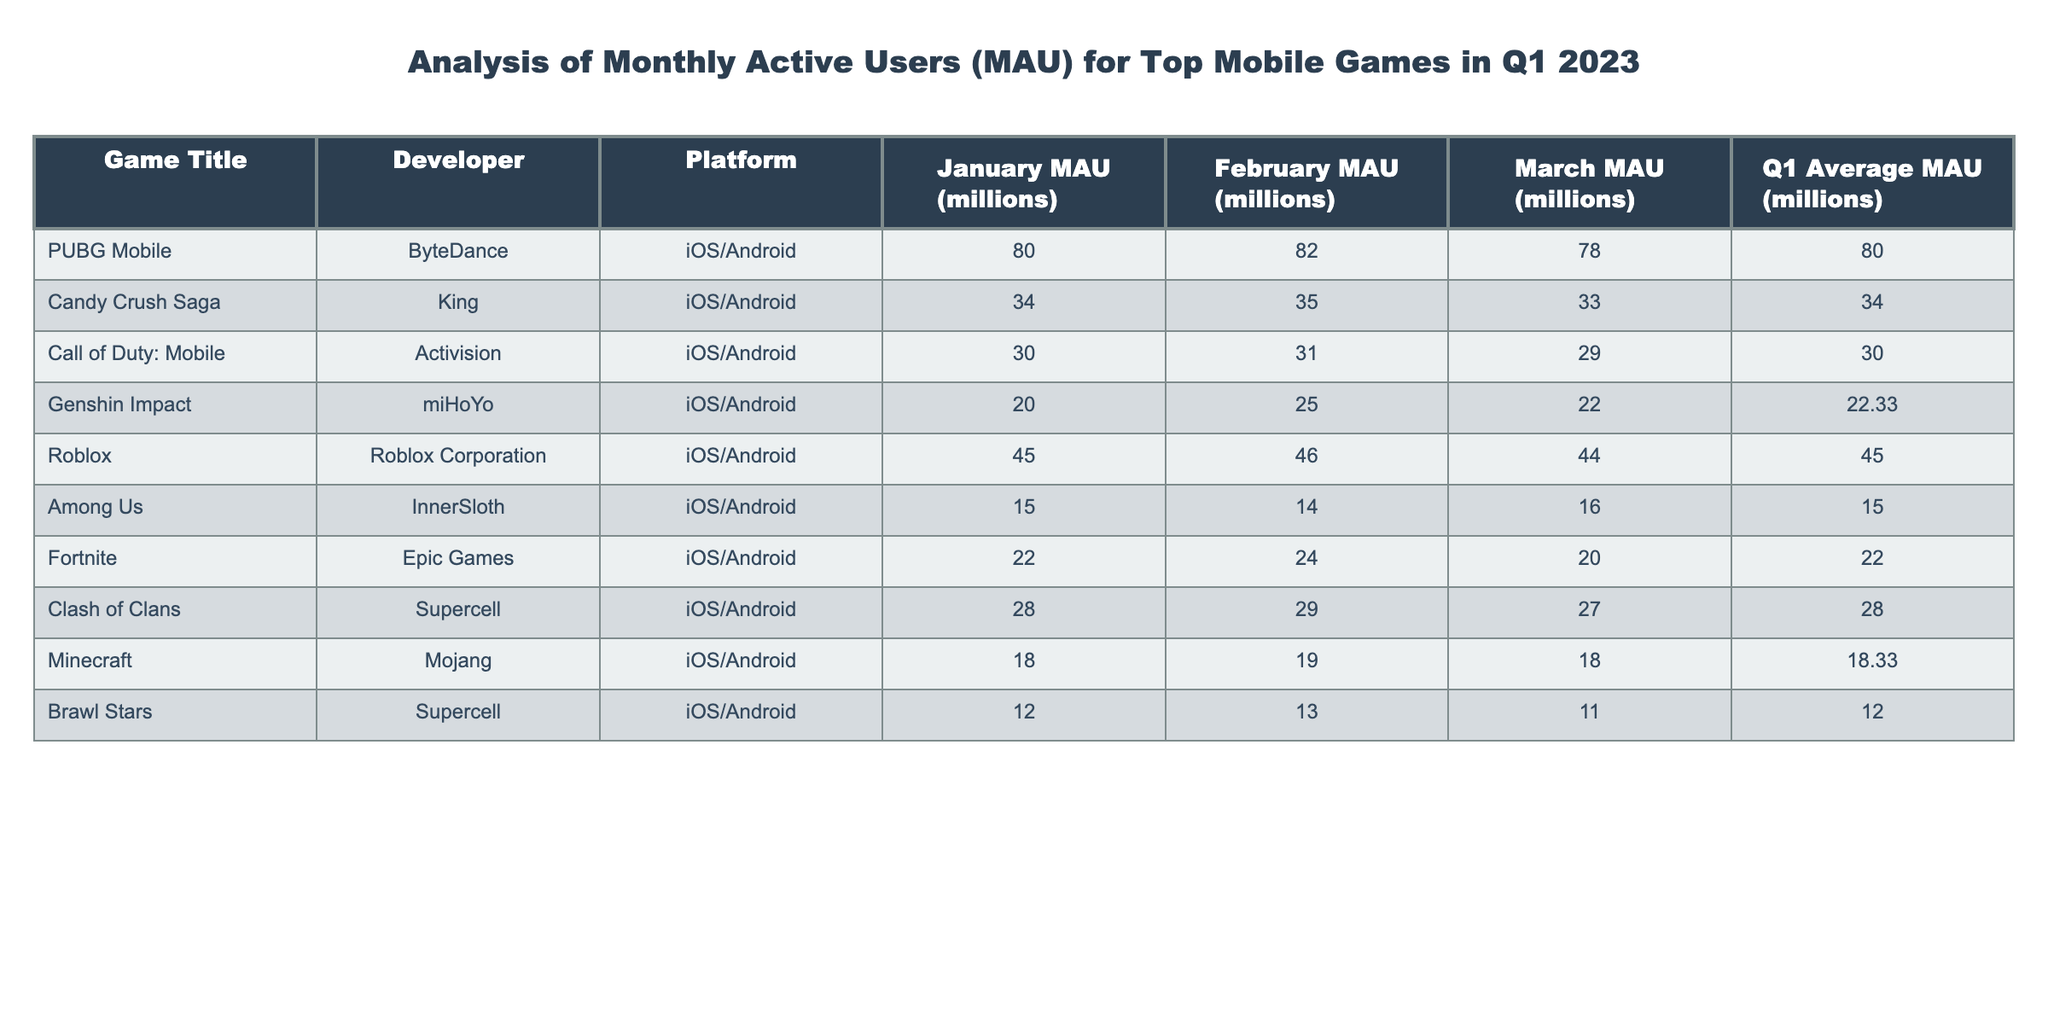What is the January MAU for Candy Crush Saga? The table shows that the January MAU for Candy Crush Saga is 34 million.
Answer: 34 million Which game had the highest Q1 Average MAU? By comparing the Q1 Average MAU values across all games, PUBG Mobile had the highest average at 80 million.
Answer: PUBG Mobile What is the difference between the February and March MAU for Call of Duty: Mobile? The February MAU for Call of Duty: Mobile is 31 million, and the March MAU is 29 million. The difference is calculated as 31 - 29 = 2 million.
Answer: 2 million Did Among Us have a higher MAU in February than in January? Among Us had a January MAU of 15 million and a February MAU of 14 million, meaning it did not have a higher MAU in February compared to January.
Answer: No What are the average MAUs for the games developed by Supercell? The games developed by Supercell are Brawl Stars and Clash of Clans. Their Q1 Average MAUs are 12 million and 28 million, respectively. Their average is (12 + 28) / 2 = 20 million.
Answer: 20 million Is the March MAU of Genshin Impact greater than the average MAU of Among Us? Genshin Impact's March MAU is 22 million, while Among Us has a Q1 Average MAU of 15 million. Since 22 million is greater than 15 million, the statement is true.
Answer: Yes What was the total sum of MAUs for Roblox across all three months? For Roblox, the January MAU is 45 million, February is 46 million, and March is 44 million. The total sum is calculated as 45 + 46 + 44 = 135 million.
Answer: 135 million Which platform had the lowest average MAU in Q1 2023 based on the data? By analyzing the Q1 Average MAUs, Brawl Stars had the lowest at 12 million, indicating it had the lowest average among all the listed games.
Answer: iOS/Android 